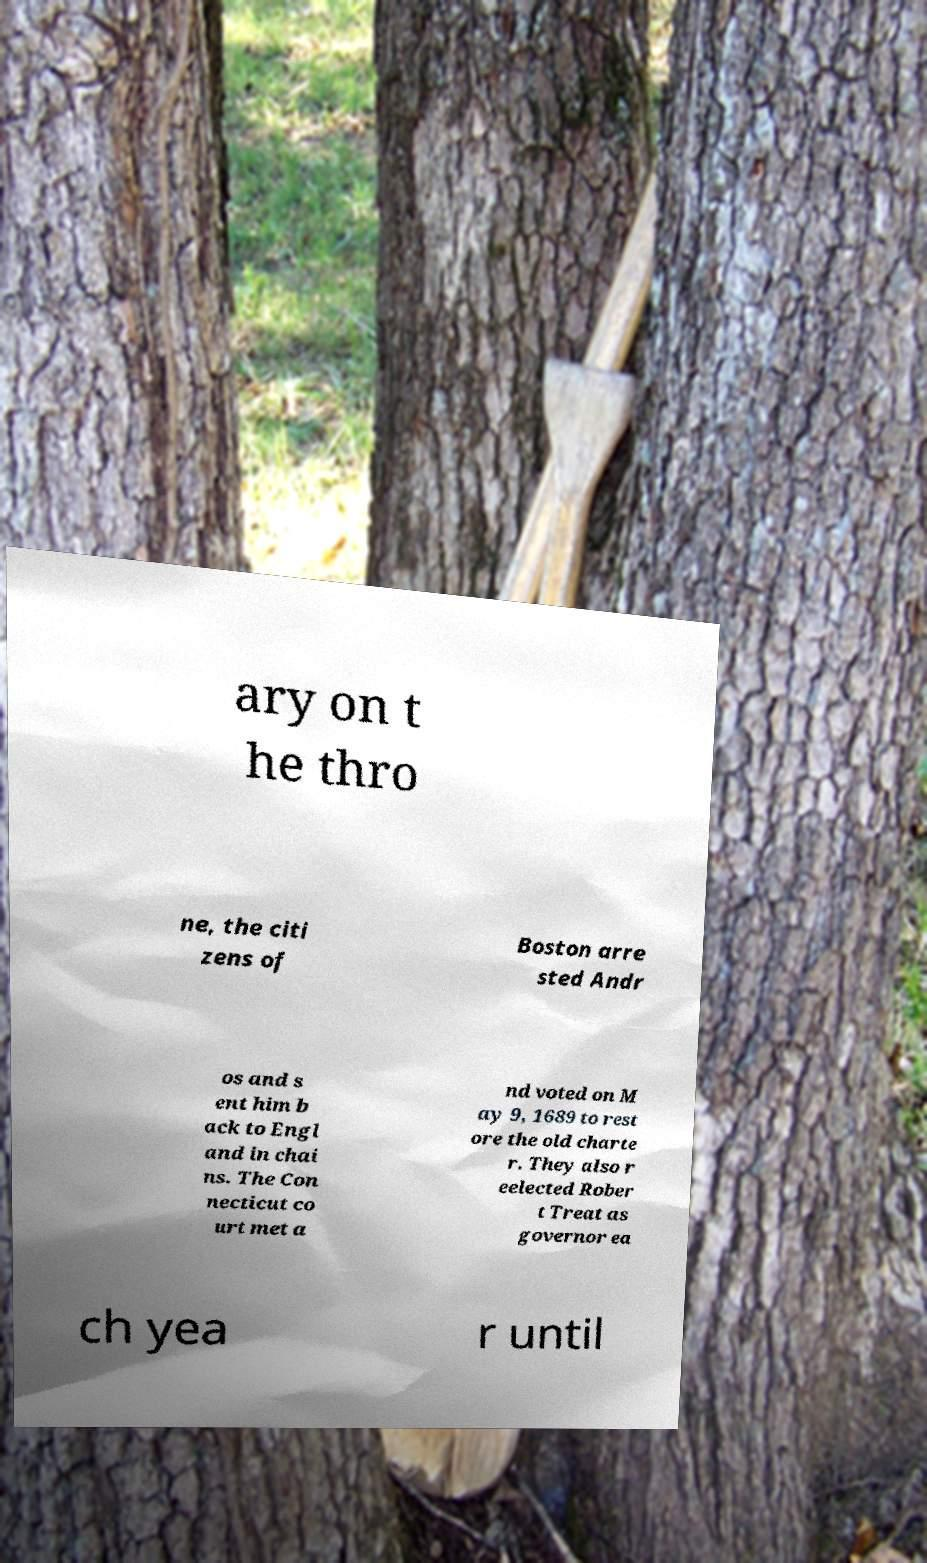Can you accurately transcribe the text from the provided image for me? ary on t he thro ne, the citi zens of Boston arre sted Andr os and s ent him b ack to Engl and in chai ns. The Con necticut co urt met a nd voted on M ay 9, 1689 to rest ore the old charte r. They also r eelected Rober t Treat as governor ea ch yea r until 